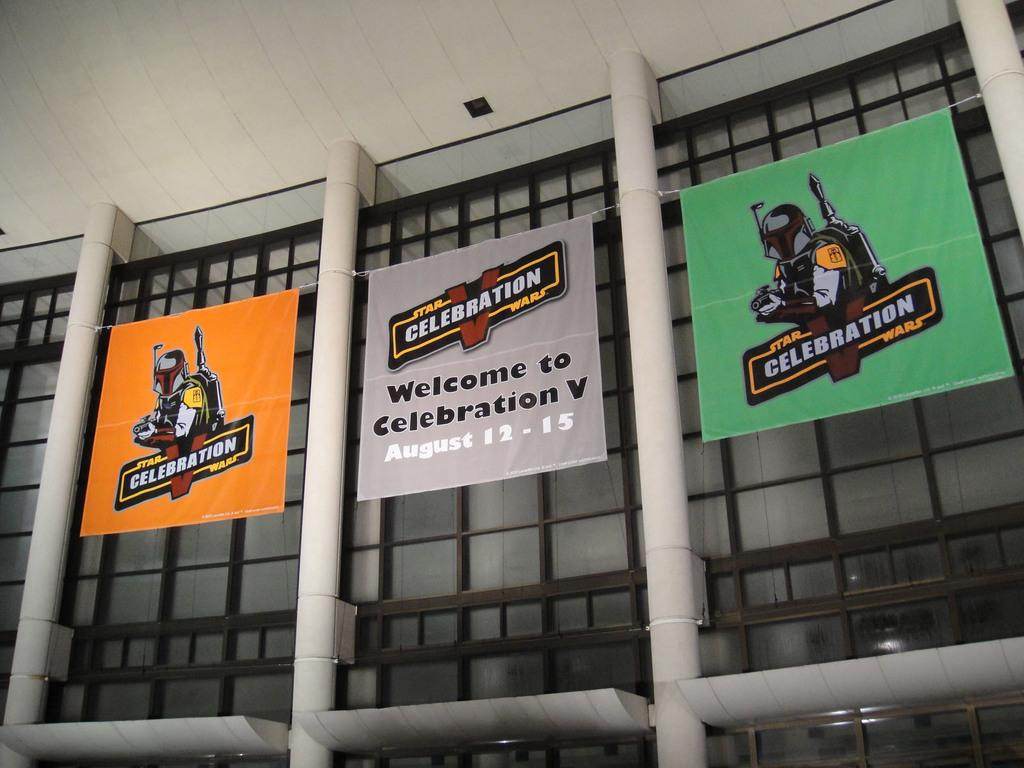What is hanging from the pillars in the image? There are banners in the image that are attached to pillars. How are the banners attached to the pillars? The banners are attached to the pillars by a rope. What else can be seen attached to the window in the image? There are glasses attached to the window in the image. How many rings are visible on the banners in the image? There are no rings visible on the banners in the image. What type of feast is being celebrated in the image? There is no indication of a feast or celebration in the image. 